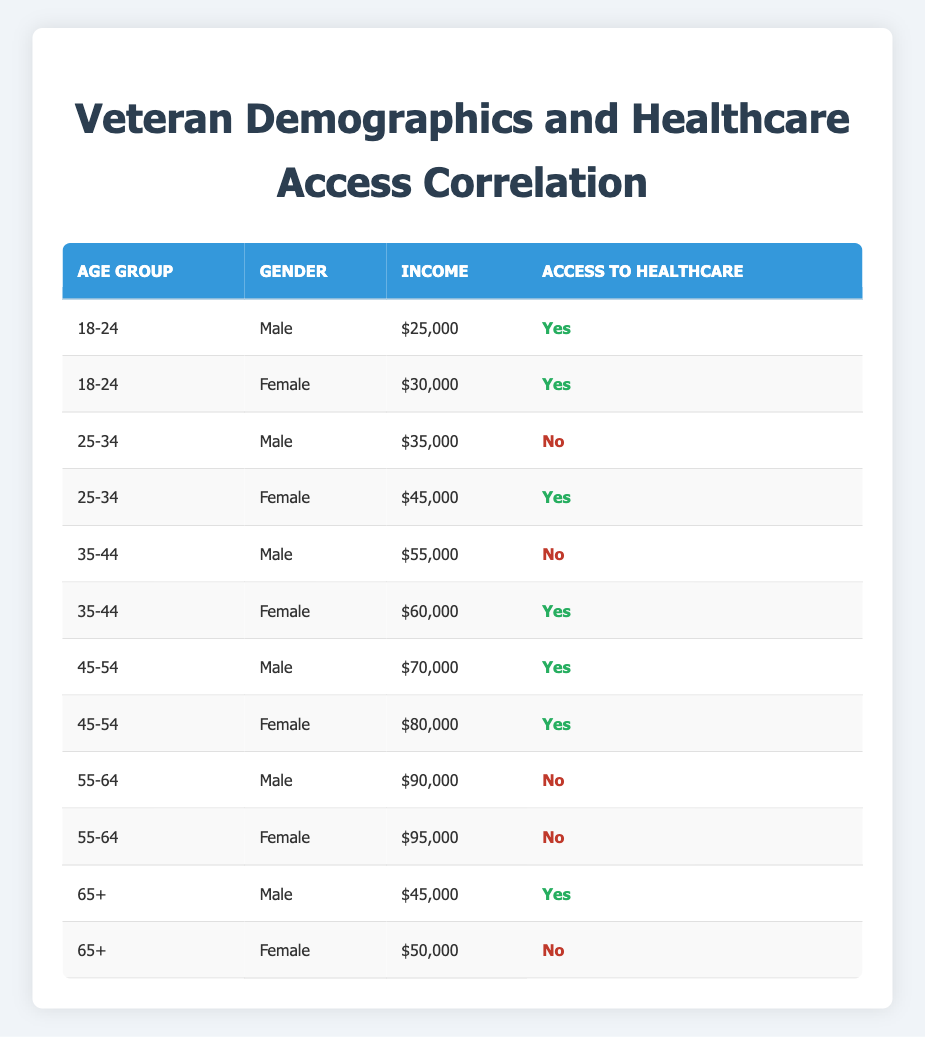What is the income of female veterans aged 25-34? The table shows the income for the female veteran in the age group 25-34, which is $45,000.
Answer: $45,000 How many male veterans in the age group 55-64 have access to healthcare? The table lists the male veterans aged 55-64, and it shows that this age group does not have access to healthcare (0).
Answer: 0 Is there any female veteran in the age group 18-24 with access to healthcare? Referring to the table, both female veterans aged 18-24 have access to healthcare, confirming that the answer is yes.
Answer: Yes What is the average income of male veterans across all age groups? To find the average income of male veterans, sum the incomes of all males (25000 + 35000 + 55000 + 70000 + 90000 + 45000 = 325000) and divide by the number of male veterans (6), which results in an average income of 54166.67.
Answer: 54166.67 Which age group has the maximum number of veterans with access to healthcare? By counting the rows in the table where access to healthcare is marked as "Yes", the age groups 18-24, 25-34, 35-44, and 45-54 each have one female veteran, while the age group 65+ has one male veteran. But 45-54 has the highest count of veterans (both male and female) with access, totaling 2.
Answer: 45-54 Are there any female veterans aged 65 or older who access healthcare? The table shows that the female veteran aged 65+ does not have access to healthcare, confirming the answer is no.
Answer: No Which gender has a higher percentage of access to healthcare for the 35-44 age group? In the age group 35-44, there is one male (no access to healthcare) and one female (access to healthcare). To find the percentage, the female percentage is 100% (1 out of 1) while the male percentage is 0%. Thus, females have a higher percentage of access.
Answer: Female How many veterans aged 55-64 have access to healthcare compared to the 25-34 age group? The 55-64 age group has 0 veterans with access, while the 25-34 age group has 1 female veteran with access. Thus, the 25-34 group has one veteran with access compared to zero in the 55-64 group.
Answer: 1 What is the total number of veteran demographics listed in the table? The table details a total of 12 veteran demographics for access to healthcare based on age, gender, and income.
Answer: 12 